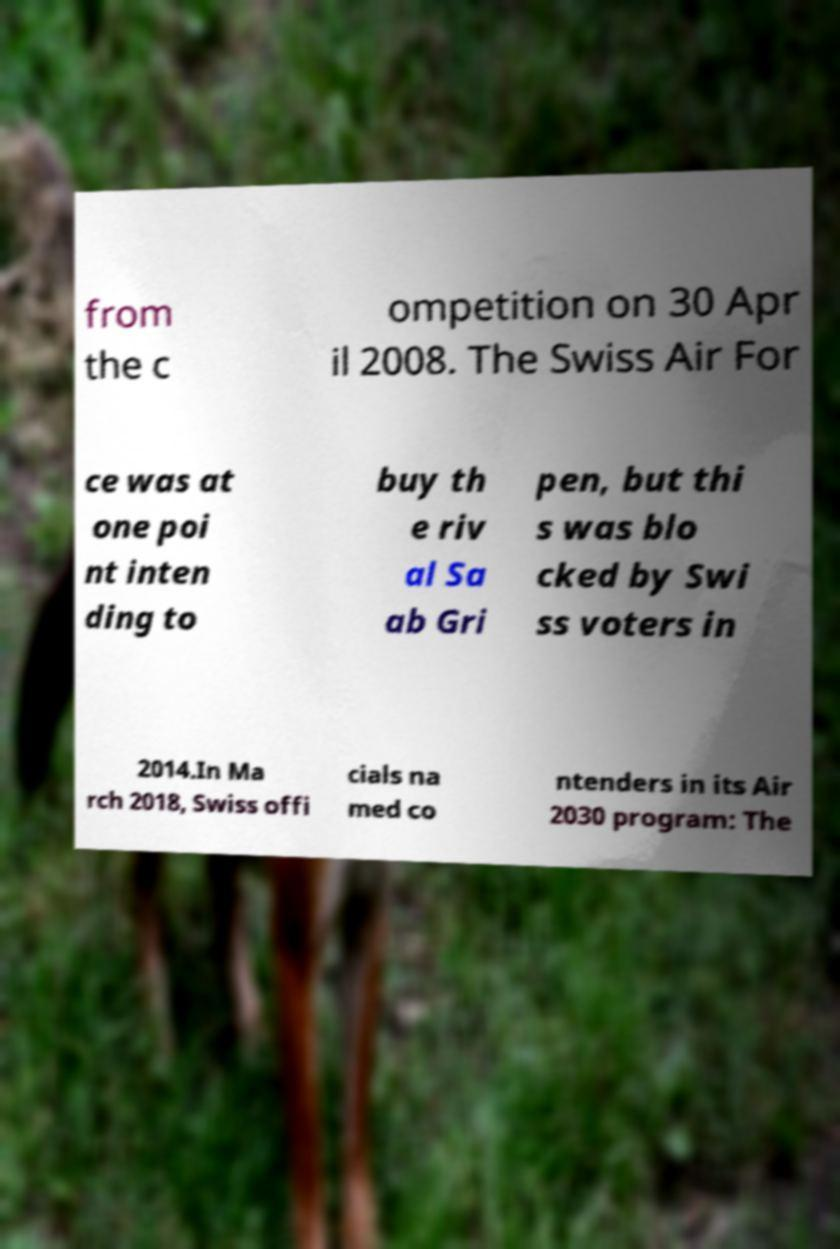Could you assist in decoding the text presented in this image and type it out clearly? from the c ompetition on 30 Apr il 2008. The Swiss Air For ce was at one poi nt inten ding to buy th e riv al Sa ab Gri pen, but thi s was blo cked by Swi ss voters in 2014.In Ma rch 2018, Swiss offi cials na med co ntenders in its Air 2030 program: The 